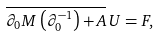Convert formula to latex. <formula><loc_0><loc_0><loc_500><loc_500>\overline { \partial _ { 0 } M \left ( \partial _ { 0 } ^ { - 1 } \right ) + A } \, U = F ,</formula> 